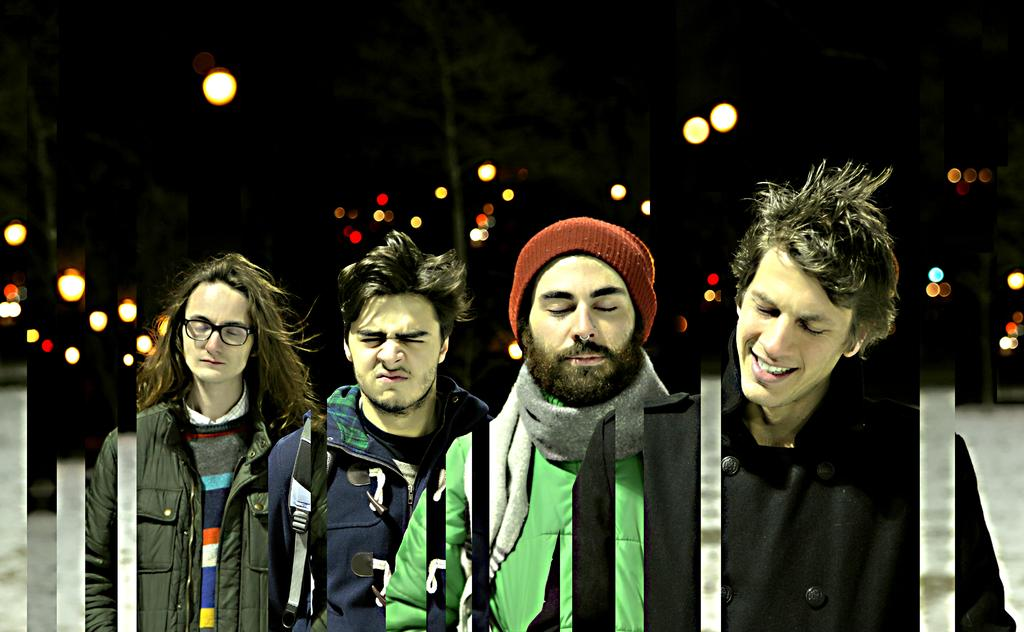What are the people in the image doing? The people in the image have their eyes closed. What can be seen in the image besides the people? There are lights visible in the image. What is visible in the background of the image? There are trees in the background of the image. How would you describe the lighting conditions in the image? The background of the image is dark. What type of brick is being used to build the vest in the image? There is no brick or vest present in the image. How many friends are visible in the image? The provided facts do not mention friends, so we cannot determine the number of friends in the image. 